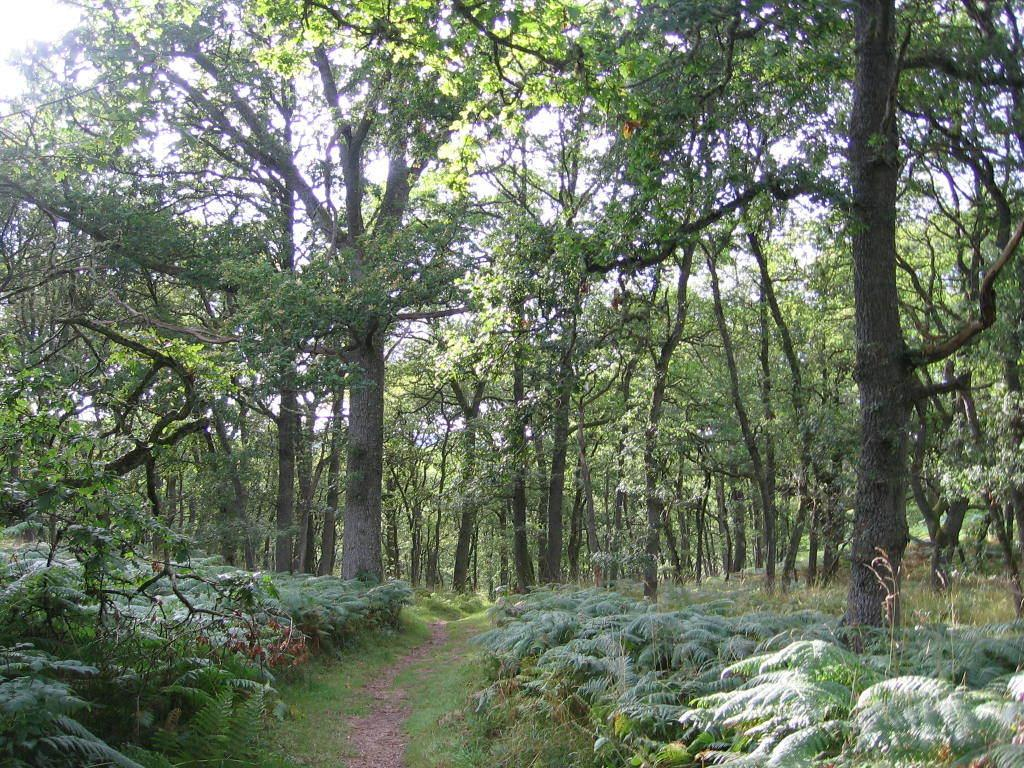What type of environment is depicted in the image? The image appears to depict a forest. Can you describe any specific features of the forest? There is a path visible in the image, and it is surrounded by trees. What else can be seen in the image besides the forest and path? Plants are present in the image. What flavor of ice cream is being served in the forest? There is no ice cream present in the image, so it is not possible to determine the flavor. 